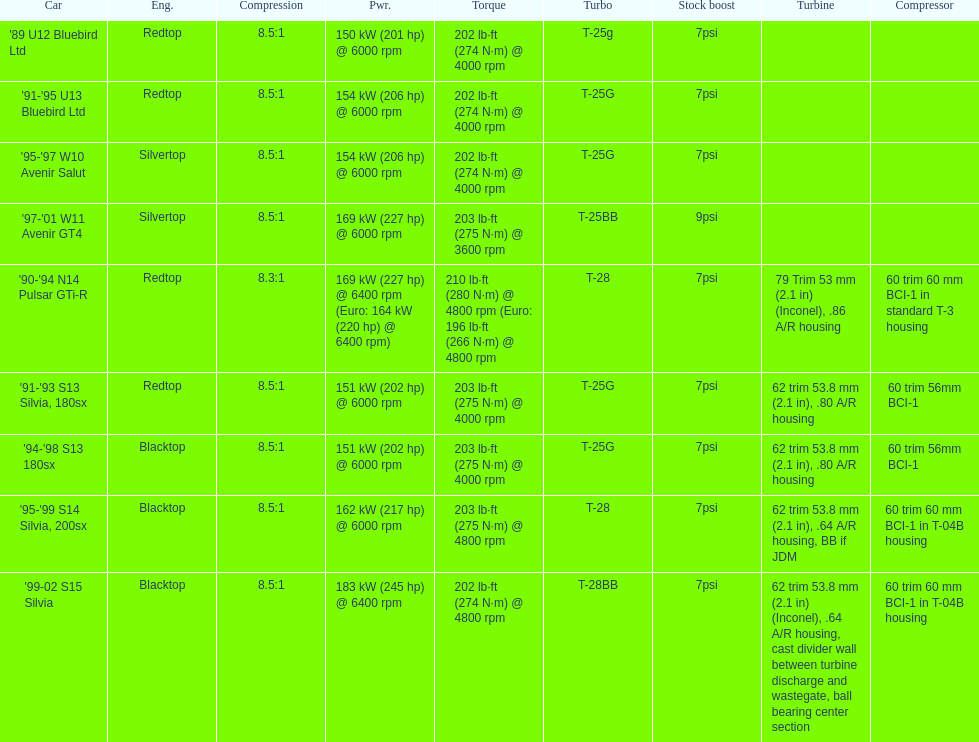What is his/her compression for the 90-94 n14 pulsar gti-r? 8.3:1. 